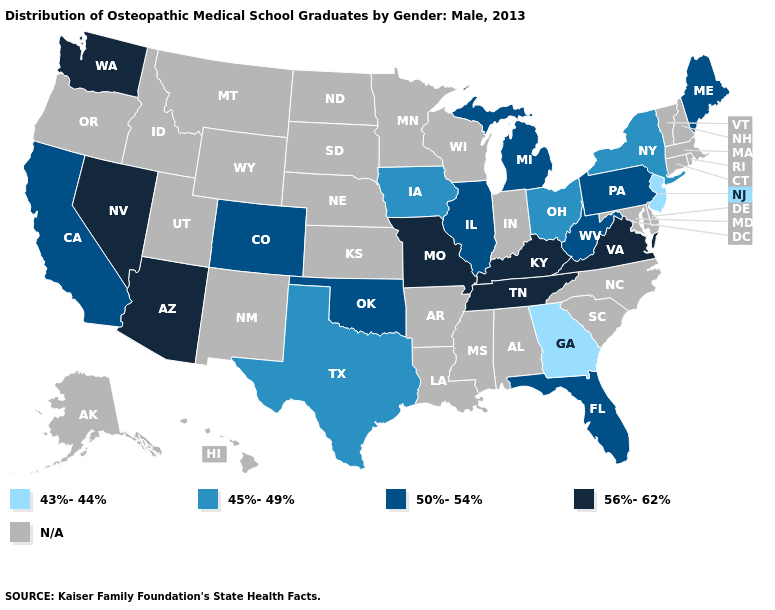Which states have the lowest value in the West?
Concise answer only. California, Colorado. What is the value of Colorado?
Write a very short answer. 50%-54%. What is the value of Alabama?
Give a very brief answer. N/A. How many symbols are there in the legend?
Keep it brief. 5. Does New Jersey have the lowest value in the USA?
Give a very brief answer. Yes. Name the states that have a value in the range 45%-49%?
Quick response, please. Iowa, New York, Ohio, Texas. Among the states that border Alabama , which have the highest value?
Write a very short answer. Tennessee. What is the value of Wyoming?
Be succinct. N/A. What is the highest value in the Northeast ?
Quick response, please. 50%-54%. What is the value of New York?
Write a very short answer. 45%-49%. 